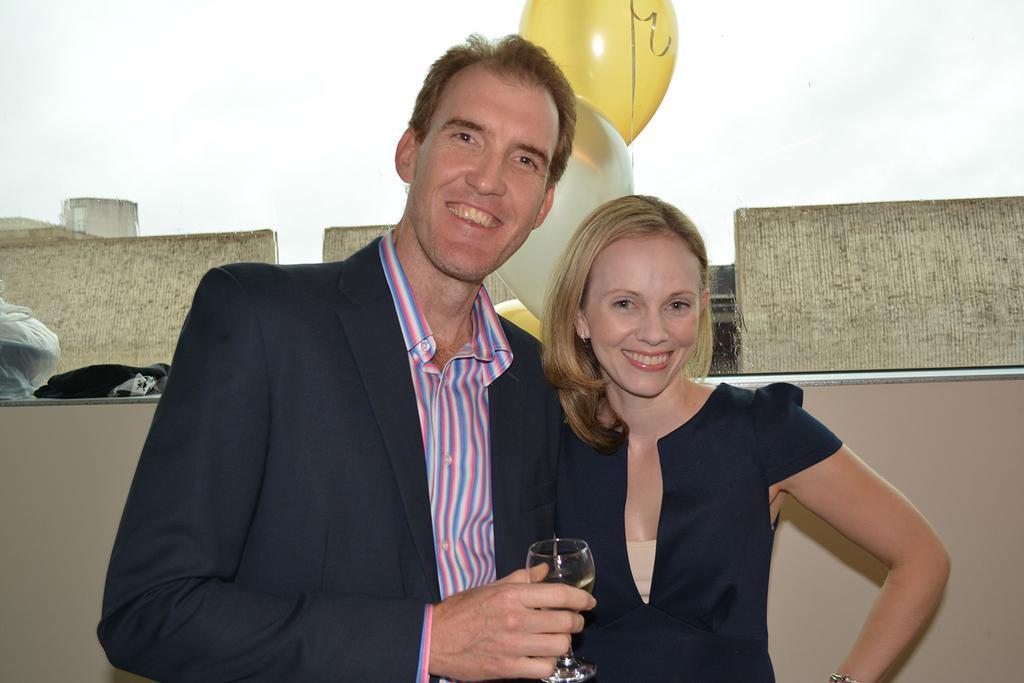In one or two sentences, can you explain what this image depicts? In this image in the front there are persons standing and smiling. On the left side there is a man standing and holding a glass in his hand. In the background there are balloons and there are objects which are white and black in colour and there is a wall. 